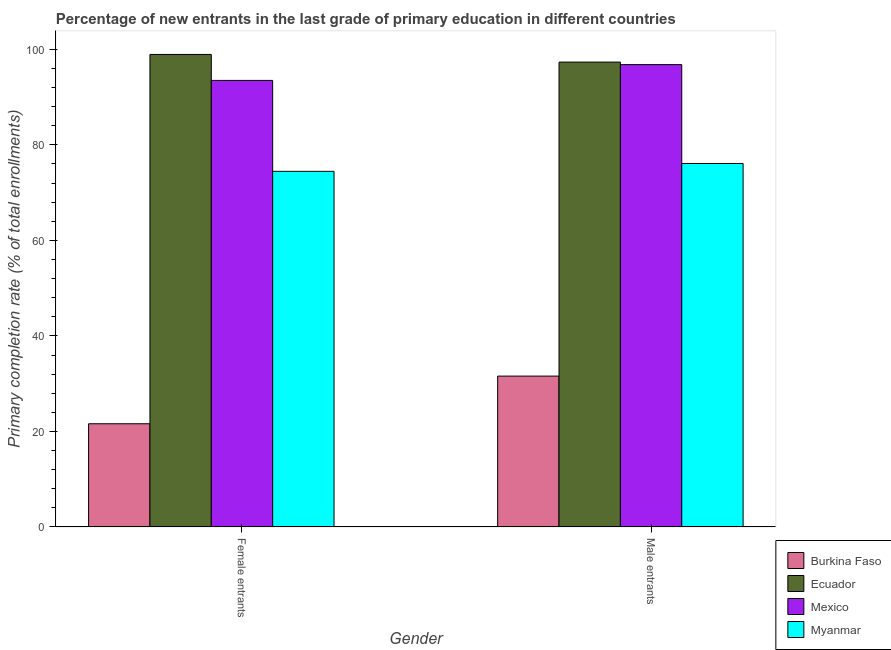How many different coloured bars are there?
Your answer should be very brief. 4. Are the number of bars per tick equal to the number of legend labels?
Offer a very short reply. Yes. Are the number of bars on each tick of the X-axis equal?
Offer a terse response. Yes. How many bars are there on the 1st tick from the left?
Keep it short and to the point. 4. How many bars are there on the 1st tick from the right?
Make the answer very short. 4. What is the label of the 1st group of bars from the left?
Provide a succinct answer. Female entrants. What is the primary completion rate of female entrants in Ecuador?
Your answer should be very brief. 98.93. Across all countries, what is the maximum primary completion rate of female entrants?
Give a very brief answer. 98.93. Across all countries, what is the minimum primary completion rate of female entrants?
Ensure brevity in your answer.  21.61. In which country was the primary completion rate of female entrants maximum?
Keep it short and to the point. Ecuador. In which country was the primary completion rate of female entrants minimum?
Provide a short and direct response. Burkina Faso. What is the total primary completion rate of female entrants in the graph?
Your answer should be compact. 288.49. What is the difference between the primary completion rate of female entrants in Burkina Faso and that in Ecuador?
Make the answer very short. -77.31. What is the difference between the primary completion rate of male entrants in Burkina Faso and the primary completion rate of female entrants in Ecuador?
Provide a succinct answer. -67.34. What is the average primary completion rate of female entrants per country?
Offer a very short reply. 72.12. What is the difference between the primary completion rate of male entrants and primary completion rate of female entrants in Myanmar?
Your response must be concise. 1.65. What is the ratio of the primary completion rate of male entrants in Myanmar to that in Burkina Faso?
Ensure brevity in your answer.  2.41. Is the primary completion rate of male entrants in Mexico less than that in Myanmar?
Your answer should be very brief. No. What does the 1st bar from the left in Male entrants represents?
Your answer should be compact. Burkina Faso. What does the 2nd bar from the right in Female entrants represents?
Provide a succinct answer. Mexico. Are the values on the major ticks of Y-axis written in scientific E-notation?
Your answer should be very brief. No. Does the graph contain any zero values?
Provide a short and direct response. No. How are the legend labels stacked?
Make the answer very short. Vertical. What is the title of the graph?
Give a very brief answer. Percentage of new entrants in the last grade of primary education in different countries. Does "Peru" appear as one of the legend labels in the graph?
Keep it short and to the point. No. What is the label or title of the Y-axis?
Make the answer very short. Primary completion rate (% of total enrollments). What is the Primary completion rate (% of total enrollments) in Burkina Faso in Female entrants?
Give a very brief answer. 21.61. What is the Primary completion rate (% of total enrollments) in Ecuador in Female entrants?
Your answer should be compact. 98.93. What is the Primary completion rate (% of total enrollments) in Mexico in Female entrants?
Give a very brief answer. 93.49. What is the Primary completion rate (% of total enrollments) of Myanmar in Female entrants?
Your response must be concise. 74.46. What is the Primary completion rate (% of total enrollments) in Burkina Faso in Male entrants?
Your response must be concise. 31.59. What is the Primary completion rate (% of total enrollments) in Ecuador in Male entrants?
Your answer should be compact. 97.33. What is the Primary completion rate (% of total enrollments) of Mexico in Male entrants?
Ensure brevity in your answer.  96.8. What is the Primary completion rate (% of total enrollments) in Myanmar in Male entrants?
Your answer should be compact. 76.1. Across all Gender, what is the maximum Primary completion rate (% of total enrollments) of Burkina Faso?
Your response must be concise. 31.59. Across all Gender, what is the maximum Primary completion rate (% of total enrollments) of Ecuador?
Give a very brief answer. 98.93. Across all Gender, what is the maximum Primary completion rate (% of total enrollments) in Mexico?
Make the answer very short. 96.8. Across all Gender, what is the maximum Primary completion rate (% of total enrollments) of Myanmar?
Provide a short and direct response. 76.1. Across all Gender, what is the minimum Primary completion rate (% of total enrollments) of Burkina Faso?
Make the answer very short. 21.61. Across all Gender, what is the minimum Primary completion rate (% of total enrollments) of Ecuador?
Ensure brevity in your answer.  97.33. Across all Gender, what is the minimum Primary completion rate (% of total enrollments) of Mexico?
Offer a terse response. 93.49. Across all Gender, what is the minimum Primary completion rate (% of total enrollments) of Myanmar?
Your answer should be compact. 74.46. What is the total Primary completion rate (% of total enrollments) of Burkina Faso in the graph?
Offer a very short reply. 53.2. What is the total Primary completion rate (% of total enrollments) of Ecuador in the graph?
Provide a short and direct response. 196.25. What is the total Primary completion rate (% of total enrollments) in Mexico in the graph?
Keep it short and to the point. 190.29. What is the total Primary completion rate (% of total enrollments) of Myanmar in the graph?
Give a very brief answer. 150.56. What is the difference between the Primary completion rate (% of total enrollments) in Burkina Faso in Female entrants and that in Male entrants?
Ensure brevity in your answer.  -9.97. What is the difference between the Primary completion rate (% of total enrollments) in Ecuador in Female entrants and that in Male entrants?
Provide a succinct answer. 1.6. What is the difference between the Primary completion rate (% of total enrollments) in Mexico in Female entrants and that in Male entrants?
Ensure brevity in your answer.  -3.3. What is the difference between the Primary completion rate (% of total enrollments) of Myanmar in Female entrants and that in Male entrants?
Your answer should be compact. -1.65. What is the difference between the Primary completion rate (% of total enrollments) in Burkina Faso in Female entrants and the Primary completion rate (% of total enrollments) in Ecuador in Male entrants?
Give a very brief answer. -75.71. What is the difference between the Primary completion rate (% of total enrollments) of Burkina Faso in Female entrants and the Primary completion rate (% of total enrollments) of Mexico in Male entrants?
Provide a short and direct response. -75.18. What is the difference between the Primary completion rate (% of total enrollments) of Burkina Faso in Female entrants and the Primary completion rate (% of total enrollments) of Myanmar in Male entrants?
Your answer should be compact. -54.49. What is the difference between the Primary completion rate (% of total enrollments) of Ecuador in Female entrants and the Primary completion rate (% of total enrollments) of Mexico in Male entrants?
Give a very brief answer. 2.13. What is the difference between the Primary completion rate (% of total enrollments) of Ecuador in Female entrants and the Primary completion rate (% of total enrollments) of Myanmar in Male entrants?
Your answer should be compact. 22.82. What is the difference between the Primary completion rate (% of total enrollments) in Mexico in Female entrants and the Primary completion rate (% of total enrollments) in Myanmar in Male entrants?
Offer a terse response. 17.39. What is the average Primary completion rate (% of total enrollments) of Burkina Faso per Gender?
Offer a very short reply. 26.6. What is the average Primary completion rate (% of total enrollments) of Ecuador per Gender?
Ensure brevity in your answer.  98.13. What is the average Primary completion rate (% of total enrollments) of Mexico per Gender?
Keep it short and to the point. 95.14. What is the average Primary completion rate (% of total enrollments) of Myanmar per Gender?
Ensure brevity in your answer.  75.28. What is the difference between the Primary completion rate (% of total enrollments) in Burkina Faso and Primary completion rate (% of total enrollments) in Ecuador in Female entrants?
Keep it short and to the point. -77.31. What is the difference between the Primary completion rate (% of total enrollments) in Burkina Faso and Primary completion rate (% of total enrollments) in Mexico in Female entrants?
Offer a very short reply. -71.88. What is the difference between the Primary completion rate (% of total enrollments) of Burkina Faso and Primary completion rate (% of total enrollments) of Myanmar in Female entrants?
Give a very brief answer. -52.84. What is the difference between the Primary completion rate (% of total enrollments) in Ecuador and Primary completion rate (% of total enrollments) in Mexico in Female entrants?
Provide a succinct answer. 5.43. What is the difference between the Primary completion rate (% of total enrollments) in Ecuador and Primary completion rate (% of total enrollments) in Myanmar in Female entrants?
Give a very brief answer. 24.47. What is the difference between the Primary completion rate (% of total enrollments) in Mexico and Primary completion rate (% of total enrollments) in Myanmar in Female entrants?
Offer a very short reply. 19.04. What is the difference between the Primary completion rate (% of total enrollments) of Burkina Faso and Primary completion rate (% of total enrollments) of Ecuador in Male entrants?
Your response must be concise. -65.74. What is the difference between the Primary completion rate (% of total enrollments) of Burkina Faso and Primary completion rate (% of total enrollments) of Mexico in Male entrants?
Keep it short and to the point. -65.21. What is the difference between the Primary completion rate (% of total enrollments) in Burkina Faso and Primary completion rate (% of total enrollments) in Myanmar in Male entrants?
Provide a short and direct response. -44.51. What is the difference between the Primary completion rate (% of total enrollments) in Ecuador and Primary completion rate (% of total enrollments) in Mexico in Male entrants?
Provide a short and direct response. 0.53. What is the difference between the Primary completion rate (% of total enrollments) in Ecuador and Primary completion rate (% of total enrollments) in Myanmar in Male entrants?
Your response must be concise. 21.22. What is the difference between the Primary completion rate (% of total enrollments) in Mexico and Primary completion rate (% of total enrollments) in Myanmar in Male entrants?
Your answer should be compact. 20.69. What is the ratio of the Primary completion rate (% of total enrollments) of Burkina Faso in Female entrants to that in Male entrants?
Provide a short and direct response. 0.68. What is the ratio of the Primary completion rate (% of total enrollments) in Ecuador in Female entrants to that in Male entrants?
Your response must be concise. 1.02. What is the ratio of the Primary completion rate (% of total enrollments) in Mexico in Female entrants to that in Male entrants?
Your answer should be compact. 0.97. What is the ratio of the Primary completion rate (% of total enrollments) in Myanmar in Female entrants to that in Male entrants?
Offer a terse response. 0.98. What is the difference between the highest and the second highest Primary completion rate (% of total enrollments) in Burkina Faso?
Ensure brevity in your answer.  9.97. What is the difference between the highest and the second highest Primary completion rate (% of total enrollments) of Ecuador?
Provide a short and direct response. 1.6. What is the difference between the highest and the second highest Primary completion rate (% of total enrollments) in Mexico?
Provide a short and direct response. 3.3. What is the difference between the highest and the second highest Primary completion rate (% of total enrollments) in Myanmar?
Offer a terse response. 1.65. What is the difference between the highest and the lowest Primary completion rate (% of total enrollments) of Burkina Faso?
Your answer should be very brief. 9.97. What is the difference between the highest and the lowest Primary completion rate (% of total enrollments) in Ecuador?
Make the answer very short. 1.6. What is the difference between the highest and the lowest Primary completion rate (% of total enrollments) in Mexico?
Your answer should be very brief. 3.3. What is the difference between the highest and the lowest Primary completion rate (% of total enrollments) of Myanmar?
Offer a very short reply. 1.65. 